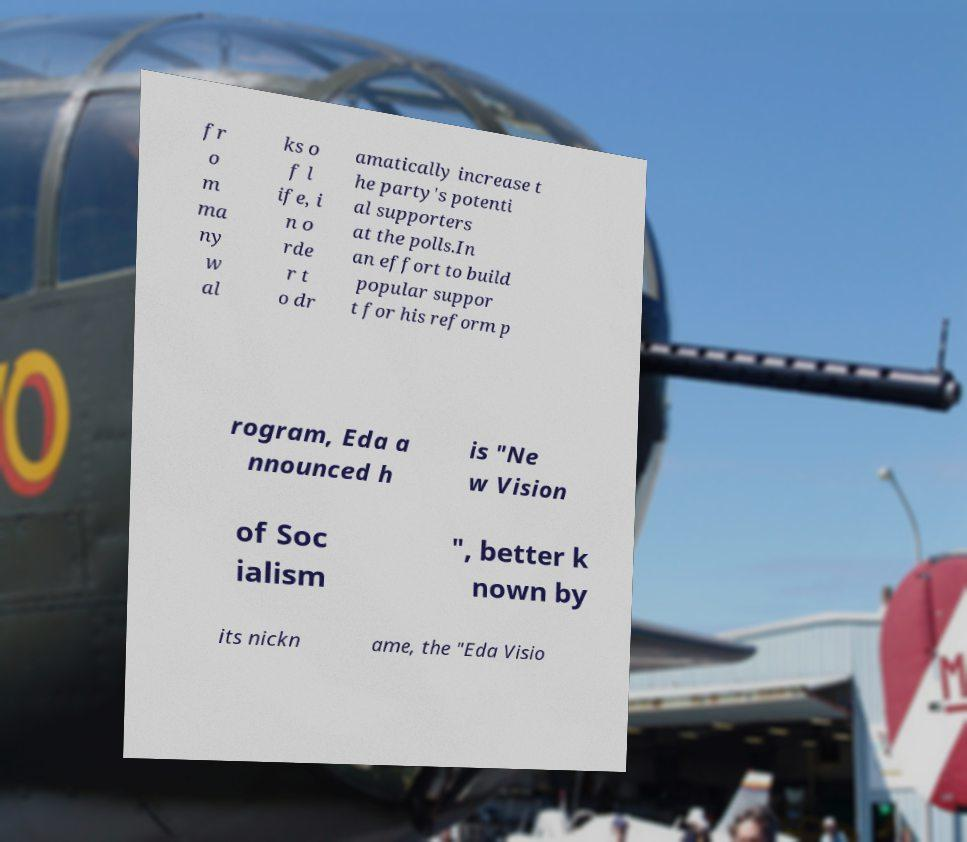I need the written content from this picture converted into text. Can you do that? fr o m ma ny w al ks o f l ife, i n o rde r t o dr amatically increase t he party's potenti al supporters at the polls.In an effort to build popular suppor t for his reform p rogram, Eda a nnounced h is "Ne w Vision of Soc ialism ", better k nown by its nickn ame, the "Eda Visio 